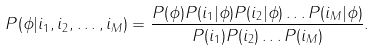Convert formula to latex. <formula><loc_0><loc_0><loc_500><loc_500>P ( \phi | i _ { 1 } , i _ { 2 } , \dots , i _ { M } ) = \frac { P ( \phi ) P ( i _ { 1 } | \phi ) P ( i _ { 2 } | \phi ) \dots P ( i _ { M } | \phi ) } { P ( i _ { 1 } ) P ( i _ { 2 } ) \dots P ( i _ { M } ) } .</formula> 